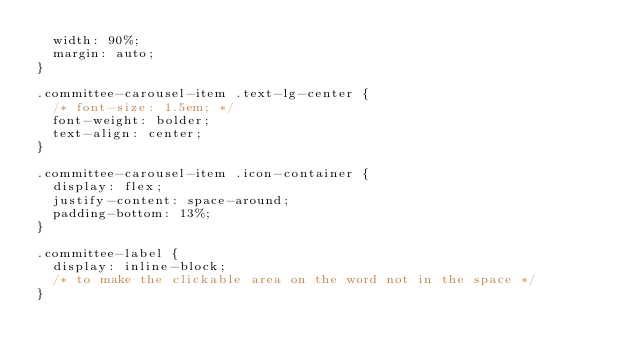Convert code to text. <code><loc_0><loc_0><loc_500><loc_500><_CSS_>  width: 90%;
  margin: auto;
}

.committee-carousel-item .text-lg-center {
  /* font-size: 1.5em; */
  font-weight: bolder;
  text-align: center;
}

.committee-carousel-item .icon-container {
  display: flex;
  justify-content: space-around;
  padding-bottom: 13%;
}

.committee-label {
  display: inline-block;
  /* to make the clickable area on the word not in the space */
}</code> 